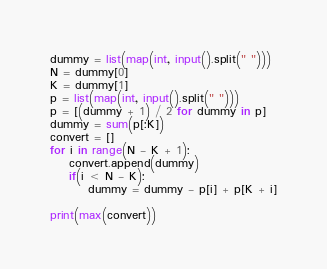Convert code to text. <code><loc_0><loc_0><loc_500><loc_500><_Python_>dummy = list(map(int, input().split(" ")))
N = dummy[0]
K = dummy[1]
p = list(map(int, input().split(" ")))
p = [(dummy + 1) / 2 for dummy in p]
dummy = sum(p[:K])
convert = []
for i in range(N - K + 1):
    convert.append(dummy)
    if(i < N - K):
        dummy = dummy - p[i] + p[K + i]

print(max(convert))</code> 